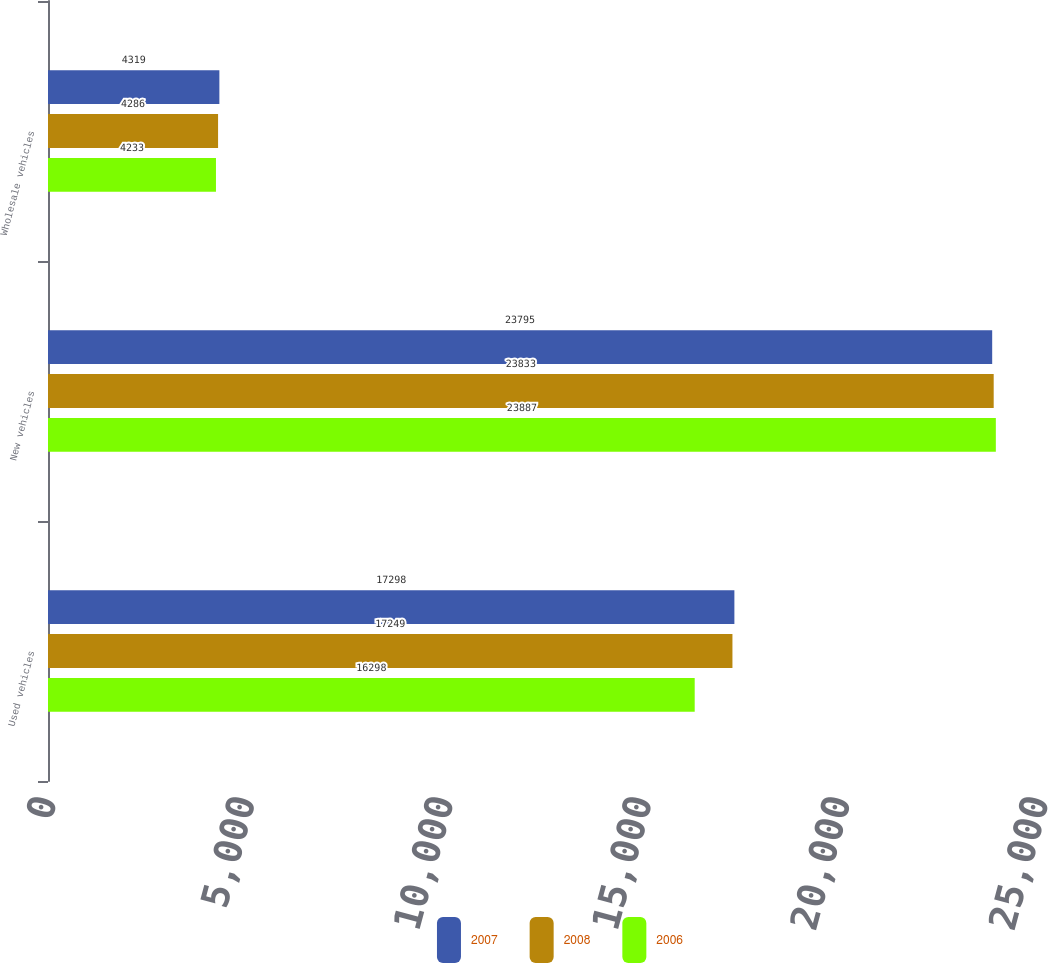Convert chart. <chart><loc_0><loc_0><loc_500><loc_500><stacked_bar_chart><ecel><fcel>Used vehicles<fcel>New vehicles<fcel>Wholesale vehicles<nl><fcel>2007<fcel>17298<fcel>23795<fcel>4319<nl><fcel>2008<fcel>17249<fcel>23833<fcel>4286<nl><fcel>2006<fcel>16298<fcel>23887<fcel>4233<nl></chart> 